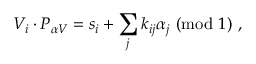Convert formula to latex. <formula><loc_0><loc_0><loc_500><loc_500>V _ { i } \cdot P _ { \alpha V } = s _ { i } + \sum _ { j } k _ { i j } \alpha _ { j } ( { m o d } 1 ) ,</formula> 